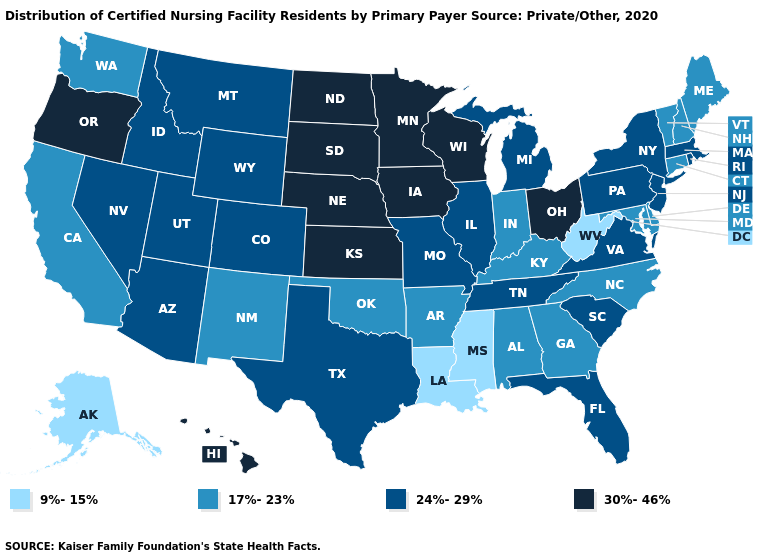Does New Hampshire have the same value as Arkansas?
Keep it brief. Yes. Does the first symbol in the legend represent the smallest category?
Keep it brief. Yes. Name the states that have a value in the range 24%-29%?
Write a very short answer. Arizona, Colorado, Florida, Idaho, Illinois, Massachusetts, Michigan, Missouri, Montana, Nevada, New Jersey, New York, Pennsylvania, Rhode Island, South Carolina, Tennessee, Texas, Utah, Virginia, Wyoming. Name the states that have a value in the range 17%-23%?
Give a very brief answer. Alabama, Arkansas, California, Connecticut, Delaware, Georgia, Indiana, Kentucky, Maine, Maryland, New Hampshire, New Mexico, North Carolina, Oklahoma, Vermont, Washington. Does South Dakota have the highest value in the USA?
Concise answer only. Yes. Name the states that have a value in the range 30%-46%?
Quick response, please. Hawaii, Iowa, Kansas, Minnesota, Nebraska, North Dakota, Ohio, Oregon, South Dakota, Wisconsin. Does Louisiana have the lowest value in the USA?
Short answer required. Yes. Which states hav the highest value in the MidWest?
Concise answer only. Iowa, Kansas, Minnesota, Nebraska, North Dakota, Ohio, South Dakota, Wisconsin. What is the highest value in states that border Nebraska?
Quick response, please. 30%-46%. Name the states that have a value in the range 9%-15%?
Answer briefly. Alaska, Louisiana, Mississippi, West Virginia. Does the first symbol in the legend represent the smallest category?
Quick response, please. Yes. Name the states that have a value in the range 24%-29%?
Short answer required. Arizona, Colorado, Florida, Idaho, Illinois, Massachusetts, Michigan, Missouri, Montana, Nevada, New Jersey, New York, Pennsylvania, Rhode Island, South Carolina, Tennessee, Texas, Utah, Virginia, Wyoming. What is the highest value in states that border Alabama?
Keep it brief. 24%-29%. What is the lowest value in the West?
Give a very brief answer. 9%-15%. What is the highest value in the MidWest ?
Keep it brief. 30%-46%. 